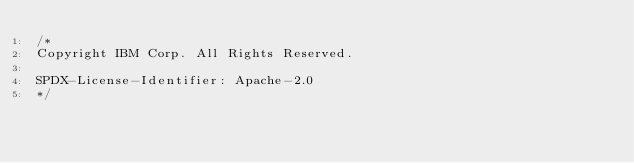<code> <loc_0><loc_0><loc_500><loc_500><_Java_>/*
Copyright IBM Corp. All Rights Reserved.

SPDX-License-Identifier: Apache-2.0
*/</code> 